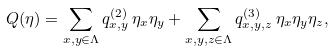Convert formula to latex. <formula><loc_0><loc_0><loc_500><loc_500>Q ( \eta ) = \sum _ { x , y \in \Lambda } q ^ { ( 2 ) } _ { x , y } \, \eta _ { x } \eta _ { y } + \sum _ { x , y , z \in \Lambda } q ^ { ( 3 ) } _ { x , y , z } \, \eta _ { x } \eta _ { y } \eta _ { z } ,</formula> 